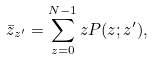<formula> <loc_0><loc_0><loc_500><loc_500>\bar { z } _ { z ^ { \prime } } = \sum _ { z = 0 } ^ { N - 1 } z P ( z ; z ^ { \prime } ) ,</formula> 